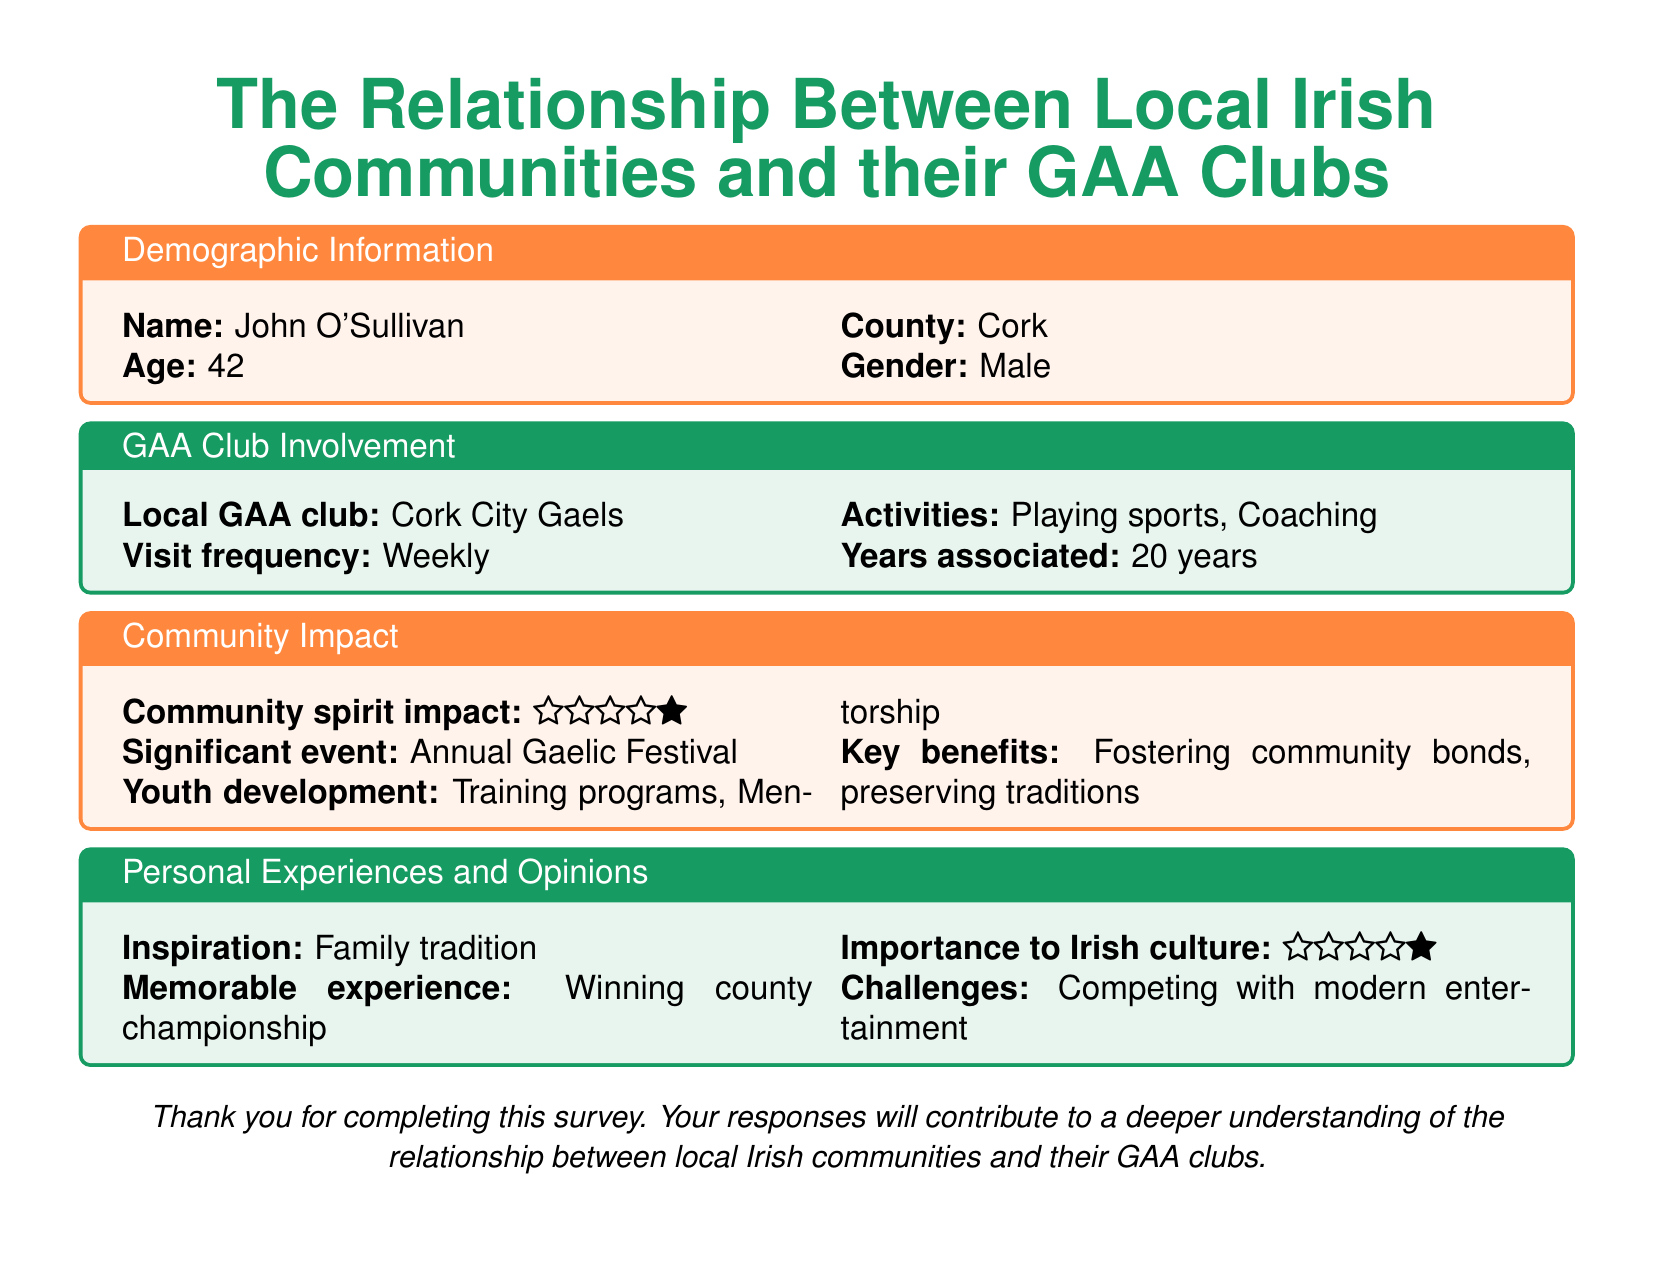What is the name of the respondent? The name of the respondent is provided in the demographic information section.
Answer: John O'Sullivan What county is the respondent from? The county is indicated in the demographic information section.
Answer: Cork How often does the respondent visit their GAA club? The visit frequency is mentioned in the GAA club involvement section of the document.
Answer: Weekly What significant event is mentioned as impacting the community? The significant event is highlighted in the community impact section.
Answer: Annual Gaelic Festival What type of activities does the respondent participate in at the GAA club? The activities are listed in the GAA club involvement section.
Answer: Playing sports, Coaching How many years has the respondent been associated with their GAA club? The number of years is specified in the GAA club involvement section.
Answer: 20 years What is the respondent's memorable experience? The memorable experience is recorded in the personal experiences and opinions section.
Answer: Winning county championship How does the respondent rate the importance of GAA clubs to Irish culture? The importance to Irish culture is rated on a five-star scale in the personal experiences and opinions section.
Answer: Five stars What challenge is mentioned related to the GAA clubs? The challenge is noted in the personal experiences and opinions section.
Answer: Competing with modern entertainment 